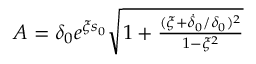Convert formula to latex. <formula><loc_0><loc_0><loc_500><loc_500>\begin{array} { r } { A = \delta _ { 0 } e ^ { \xi s _ { 0 } } \sqrt { 1 + \frac { ( \xi + \dot { \delta } _ { 0 } / \delta _ { 0 } ) ^ { 2 } } { 1 - \xi ^ { 2 } } } } \end{array}</formula> 